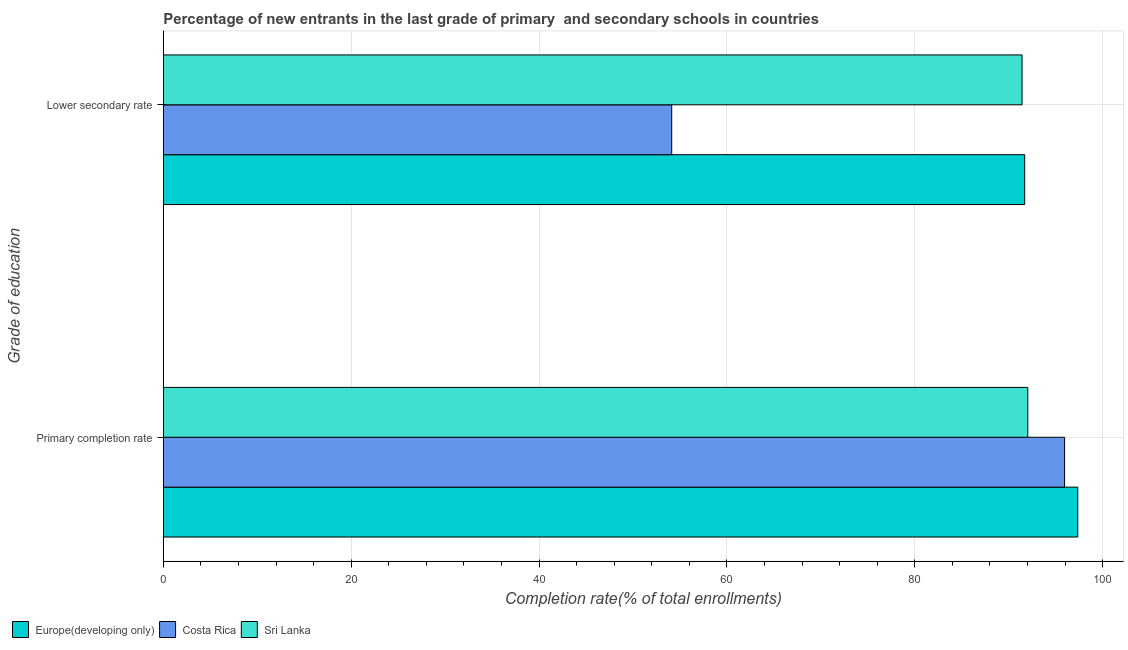Are the number of bars on each tick of the Y-axis equal?
Your response must be concise. Yes. How many bars are there on the 1st tick from the top?
Provide a short and direct response. 3. How many bars are there on the 2nd tick from the bottom?
Provide a short and direct response. 3. What is the label of the 1st group of bars from the top?
Your answer should be very brief. Lower secondary rate. What is the completion rate in secondary schools in Costa Rica?
Offer a very short reply. 54.12. Across all countries, what is the maximum completion rate in secondary schools?
Ensure brevity in your answer.  91.69. Across all countries, what is the minimum completion rate in primary schools?
Provide a succinct answer. 92.03. In which country was the completion rate in primary schools maximum?
Give a very brief answer. Europe(developing only). In which country was the completion rate in secondary schools minimum?
Your answer should be compact. Costa Rica. What is the total completion rate in primary schools in the graph?
Ensure brevity in your answer.  285.31. What is the difference between the completion rate in secondary schools in Europe(developing only) and that in Costa Rica?
Your answer should be compact. 37.57. What is the difference between the completion rate in primary schools in Costa Rica and the completion rate in secondary schools in Europe(developing only)?
Provide a short and direct response. 4.25. What is the average completion rate in secondary schools per country?
Give a very brief answer. 79.08. What is the difference between the completion rate in secondary schools and completion rate in primary schools in Costa Rica?
Offer a terse response. -41.82. What is the ratio of the completion rate in secondary schools in Costa Rica to that in Sri Lanka?
Make the answer very short. 0.59. Is the completion rate in primary schools in Europe(developing only) less than that in Sri Lanka?
Offer a very short reply. No. In how many countries, is the completion rate in secondary schools greater than the average completion rate in secondary schools taken over all countries?
Keep it short and to the point. 2. What does the 3rd bar from the top in Primary completion rate represents?
Keep it short and to the point. Europe(developing only). How many bars are there?
Your answer should be compact. 6. Are the values on the major ticks of X-axis written in scientific E-notation?
Provide a short and direct response. No. Does the graph contain any zero values?
Offer a terse response. No. Where does the legend appear in the graph?
Offer a terse response. Bottom left. How are the legend labels stacked?
Provide a short and direct response. Horizontal. What is the title of the graph?
Offer a terse response. Percentage of new entrants in the last grade of primary  and secondary schools in countries. What is the label or title of the X-axis?
Provide a short and direct response. Completion rate(% of total enrollments). What is the label or title of the Y-axis?
Offer a very short reply. Grade of education. What is the Completion rate(% of total enrollments) in Europe(developing only) in Primary completion rate?
Provide a succinct answer. 97.35. What is the Completion rate(% of total enrollments) of Costa Rica in Primary completion rate?
Provide a succinct answer. 95.94. What is the Completion rate(% of total enrollments) of Sri Lanka in Primary completion rate?
Offer a very short reply. 92.03. What is the Completion rate(% of total enrollments) of Europe(developing only) in Lower secondary rate?
Your response must be concise. 91.69. What is the Completion rate(% of total enrollments) of Costa Rica in Lower secondary rate?
Keep it short and to the point. 54.12. What is the Completion rate(% of total enrollments) in Sri Lanka in Lower secondary rate?
Your answer should be compact. 91.42. Across all Grade of education, what is the maximum Completion rate(% of total enrollments) in Europe(developing only)?
Offer a terse response. 97.35. Across all Grade of education, what is the maximum Completion rate(% of total enrollments) of Costa Rica?
Your response must be concise. 95.94. Across all Grade of education, what is the maximum Completion rate(% of total enrollments) of Sri Lanka?
Offer a terse response. 92.03. Across all Grade of education, what is the minimum Completion rate(% of total enrollments) of Europe(developing only)?
Your answer should be very brief. 91.69. Across all Grade of education, what is the minimum Completion rate(% of total enrollments) in Costa Rica?
Your response must be concise. 54.12. Across all Grade of education, what is the minimum Completion rate(% of total enrollments) of Sri Lanka?
Make the answer very short. 91.42. What is the total Completion rate(% of total enrollments) of Europe(developing only) in the graph?
Keep it short and to the point. 189.04. What is the total Completion rate(% of total enrollments) in Costa Rica in the graph?
Your response must be concise. 150.06. What is the total Completion rate(% of total enrollments) in Sri Lanka in the graph?
Ensure brevity in your answer.  183.44. What is the difference between the Completion rate(% of total enrollments) in Europe(developing only) in Primary completion rate and that in Lower secondary rate?
Offer a very short reply. 5.65. What is the difference between the Completion rate(% of total enrollments) in Costa Rica in Primary completion rate and that in Lower secondary rate?
Provide a succinct answer. 41.82. What is the difference between the Completion rate(% of total enrollments) of Sri Lanka in Primary completion rate and that in Lower secondary rate?
Keep it short and to the point. 0.61. What is the difference between the Completion rate(% of total enrollments) of Europe(developing only) in Primary completion rate and the Completion rate(% of total enrollments) of Costa Rica in Lower secondary rate?
Ensure brevity in your answer.  43.22. What is the difference between the Completion rate(% of total enrollments) in Europe(developing only) in Primary completion rate and the Completion rate(% of total enrollments) in Sri Lanka in Lower secondary rate?
Provide a short and direct response. 5.93. What is the difference between the Completion rate(% of total enrollments) of Costa Rica in Primary completion rate and the Completion rate(% of total enrollments) of Sri Lanka in Lower secondary rate?
Your answer should be very brief. 4.53. What is the average Completion rate(% of total enrollments) in Europe(developing only) per Grade of education?
Make the answer very short. 94.52. What is the average Completion rate(% of total enrollments) of Costa Rica per Grade of education?
Offer a terse response. 75.03. What is the average Completion rate(% of total enrollments) in Sri Lanka per Grade of education?
Offer a terse response. 91.72. What is the difference between the Completion rate(% of total enrollments) in Europe(developing only) and Completion rate(% of total enrollments) in Costa Rica in Primary completion rate?
Your response must be concise. 1.4. What is the difference between the Completion rate(% of total enrollments) in Europe(developing only) and Completion rate(% of total enrollments) in Sri Lanka in Primary completion rate?
Your answer should be compact. 5.32. What is the difference between the Completion rate(% of total enrollments) of Costa Rica and Completion rate(% of total enrollments) of Sri Lanka in Primary completion rate?
Your response must be concise. 3.92. What is the difference between the Completion rate(% of total enrollments) of Europe(developing only) and Completion rate(% of total enrollments) of Costa Rica in Lower secondary rate?
Provide a succinct answer. 37.57. What is the difference between the Completion rate(% of total enrollments) of Europe(developing only) and Completion rate(% of total enrollments) of Sri Lanka in Lower secondary rate?
Ensure brevity in your answer.  0.28. What is the difference between the Completion rate(% of total enrollments) of Costa Rica and Completion rate(% of total enrollments) of Sri Lanka in Lower secondary rate?
Provide a short and direct response. -37.29. What is the ratio of the Completion rate(% of total enrollments) of Europe(developing only) in Primary completion rate to that in Lower secondary rate?
Keep it short and to the point. 1.06. What is the ratio of the Completion rate(% of total enrollments) in Costa Rica in Primary completion rate to that in Lower secondary rate?
Offer a very short reply. 1.77. What is the difference between the highest and the second highest Completion rate(% of total enrollments) of Europe(developing only)?
Ensure brevity in your answer.  5.65. What is the difference between the highest and the second highest Completion rate(% of total enrollments) of Costa Rica?
Provide a succinct answer. 41.82. What is the difference between the highest and the second highest Completion rate(% of total enrollments) of Sri Lanka?
Keep it short and to the point. 0.61. What is the difference between the highest and the lowest Completion rate(% of total enrollments) in Europe(developing only)?
Your response must be concise. 5.65. What is the difference between the highest and the lowest Completion rate(% of total enrollments) of Costa Rica?
Provide a succinct answer. 41.82. What is the difference between the highest and the lowest Completion rate(% of total enrollments) of Sri Lanka?
Your answer should be compact. 0.61. 